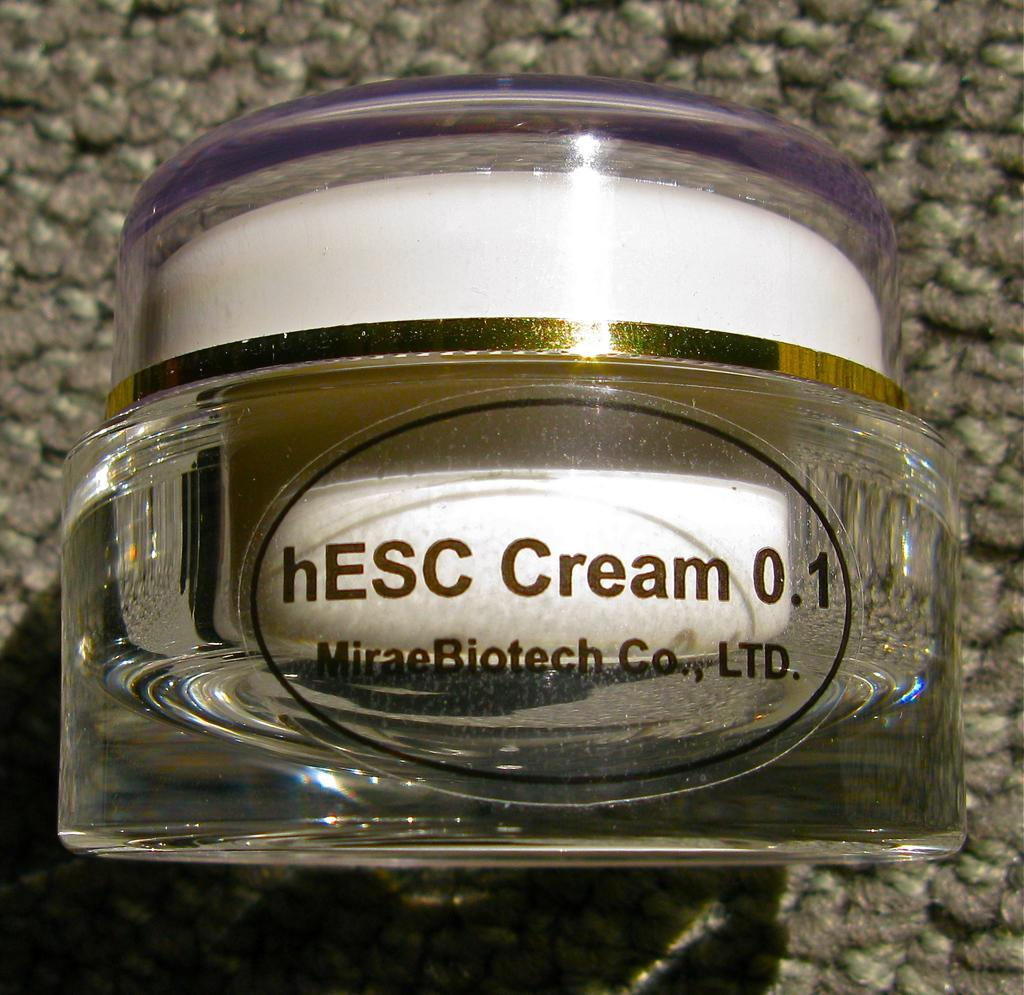<image>
Create a compact narrative representing the image presented. Bottle of hESC Cream 0.1 on top of a rug. 